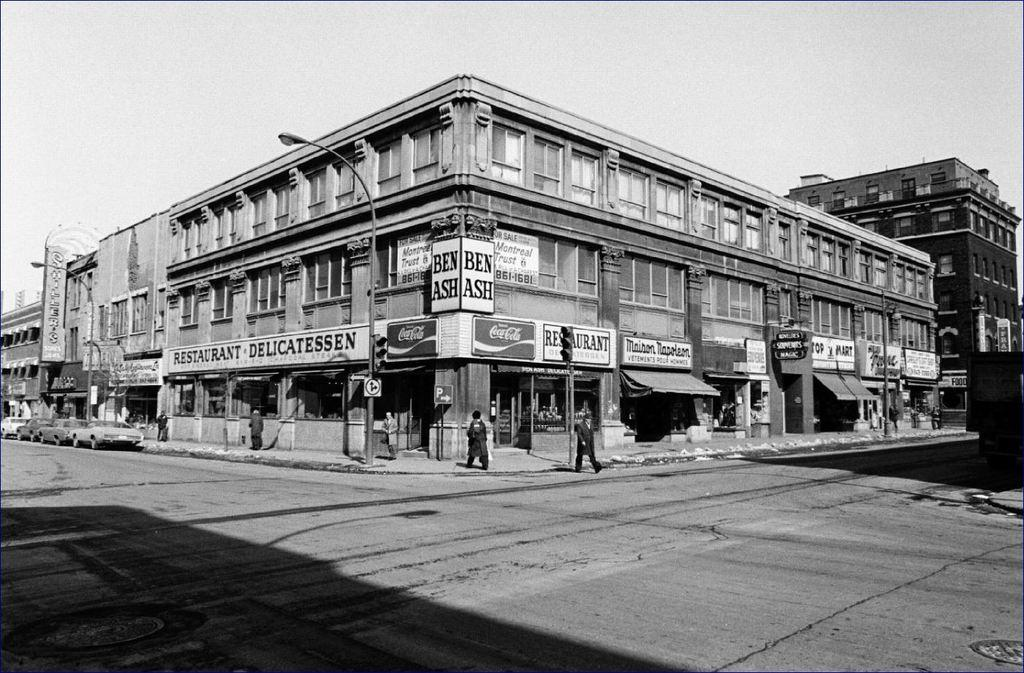<image>
Render a clear and concise summary of the photo. A black and white photograph of a store with Coca Cola banners. 